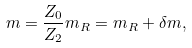Convert formula to latex. <formula><loc_0><loc_0><loc_500><loc_500>m = \frac { Z _ { 0 } } { Z _ { 2 } } m _ { R } = m _ { R } + \delta m ,</formula> 